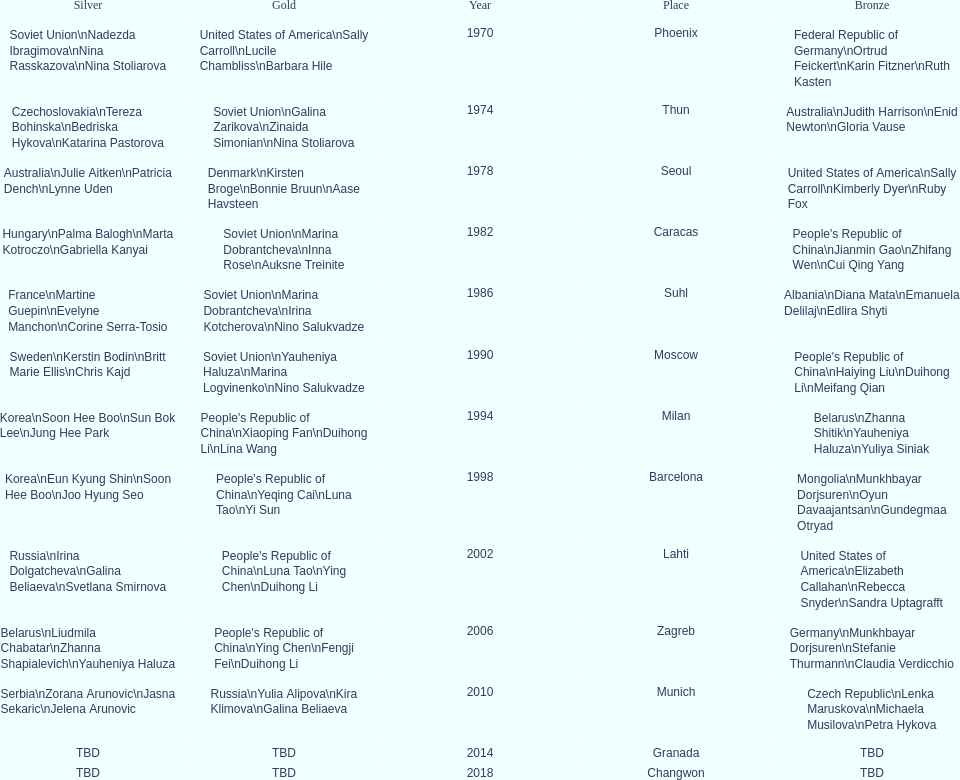Whose name is listed before bonnie bruun's in the gold column? Kirsten Broge. 